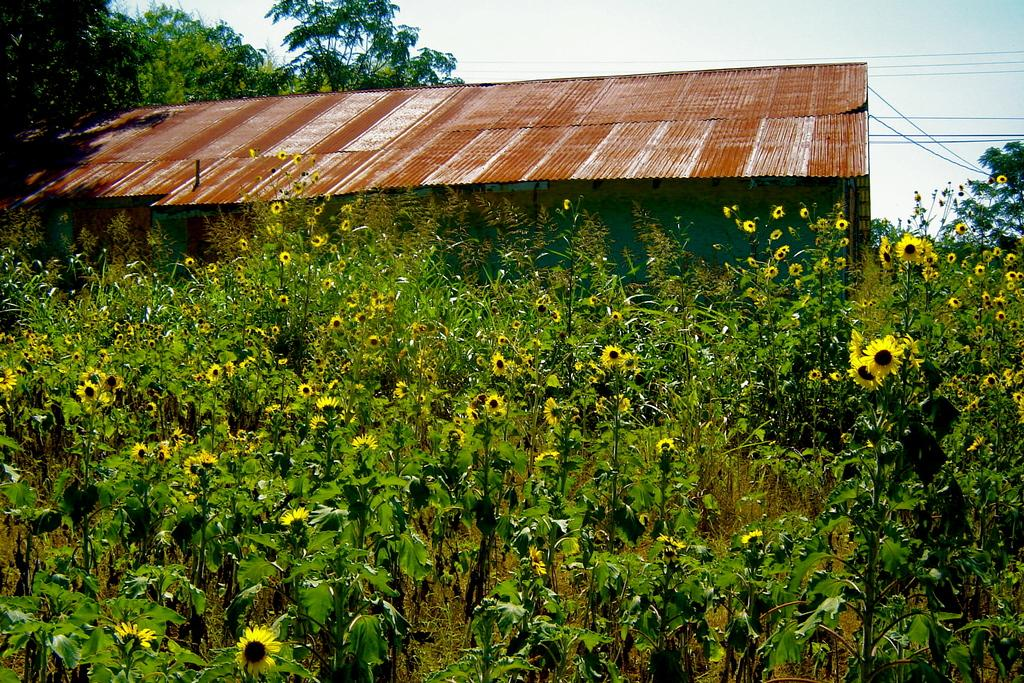What type of plants can be seen in the image? There are plants with flowers in the image. What type of structure is present in the image? There is a shed in the image. What else can be seen in the image besides the plants and shed? Cables are present in the image. What is on the left side of the shed in the image? There are trees on the left side of the shed. What is visible behind the shed in the image? The sky is visible behind the shed. How many eyes can be seen on the plants in the image? Plants do not have eyes, so there are no eyes visible on the plants in the image. What type of flooring is present in the shed in the image? The image does not show the interior of the shed, so we cannot determine the type of flooring present. 